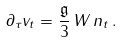<formula> <loc_0><loc_0><loc_500><loc_500>\partial _ { \tau } v _ { t } = \frac { \mathfrak { g } } { 3 } \, W \, n _ { t } \, .</formula> 